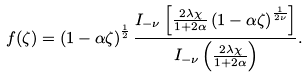Convert formula to latex. <formula><loc_0><loc_0><loc_500><loc_500>f ( \zeta ) = \left ( 1 - \alpha \zeta \right ) ^ { { \frac { 1 } { 2 } } } \frac { I _ { - \nu } \left [ \frac { 2 \lambda \chi } { 1 + 2 \alpha } \left ( 1 - \alpha \zeta \right ) ^ { { \frac { 1 } { 2 \nu } } } \right ] } { I _ { - \nu } \left ( \frac { 2 \lambda \chi } { 1 + 2 \alpha } \right ) } .</formula> 